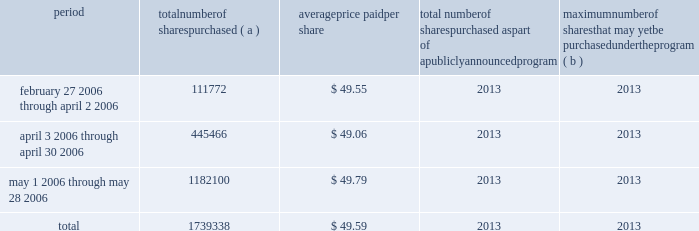2022 reed city , michigan 2022 chanhassen , minnesota 2013 bakeries & foodservice segment 2022 hannibal , missouri 2022 joplin , missouri 2013 bakeries & foodservice segment 2022 vineland , new jersey 2022 albuquerque , new mexico 2022 buffalo , new york 2022 martel , ohio 2013 bakeries & foodservice segment 2022 wellston , ohio 2022 murfreesboro , tennessee 2022 milwaukee , wisconsin we own flour mills at eight locations : vallejo , california ( not currently operating ) ; vernon , california ; avon , iowa ; minneapolis , minnesota ( 2 ) ; kansas city , missouri ; great falls , montana ; and buffalo , new york .
We also operate six terminal grain elevators ( in minnesota and wisconsin , two of which are leased ) , and have country grain elevators in seven locations ( primarily in idaho ) , plus additional seasonal elevators ( primarily in idaho ) .
We also own or lease warehouse space aggregating approximately 12.2 million square feet , of which approxi- mately 9.6 million square feet are leased .
We lease a number of sales and administrative offices in the united states , canada and elsewhere around the world , totaling approxi- mately 2.8 million square feet .
Item 3 legal proceedings we are the subject of various pending or threatened legal actions in the ordinary course of our business .
All such matters are subject to many uncertainties and outcomes that are not predictable with assurance .
In our manage- ment 2019s opinion , there were no claims or litigation pending as of may 28 , 2006 , that are reasonably likely to have a material adverse effect on our consolidated financial posi- tion or results of operations .
Item 4 submission of matters to a vote of security holders part ii item 5 market for registrant 2019s common equity , related stockholder matters and issuer purchases of equity securities our common stock is listed on the new york stock exchange .
On july 14 , 2006 , there were approximately 34675 record holders of our common stock .
Information regarding the market prices for our common stock and dividend payments for the two most recent fiscal years is set forth in note eighteen to the consolidated financial statements on page 53 in item eight of this report .
Infor- mation regarding restrictions on our ability to pay dividends in certain situations is set forth in note eight to the consol- idated financial statements on pages 43 and 44 in item eight of this report .
The table sets forth information with respect to shares of our common stock that we purchased during the three fiscal months ended may 28 , 2006 : issuer purchases of equity securities period number of shares purchased ( a ) average price paid per share total number of shares purchased as part of a publicly announced program maximum number of shares that may yet be purchased under the program ( b ) february 27 , 2006 through april 2 , 2006 111772 $ 49.55 2013 2013 april 3 , 2006 through april 30 , 2006 445466 $ 49.06 2013 2013 may 1 , 2006 through may 28 , 2006 1182100 $ 49.79 2013 2013 .
( a ) the total number of shares purchased includes : ( i ) 231500 shares purchased from the esop fund of our 401 ( k ) savings plan ; ( ii ) 8338 shares of restricted stock withheld for the payment of with- holding taxes upon vesting of restricted stock ; and ( iii ) 1499500 shares purchased in the open market .
( b ) on february 21 , 2000 , we announced that our board of directors autho- rized us to repurchase up to 170 million shares of our common stock to be held in our treasury .
The board did not specify a time period or an expiration date for the authorization. .
What is the total cash spent to purchase back all shares in 2006? 
Computations: (1739338 * 49.59)
Answer: 86253771.42. 